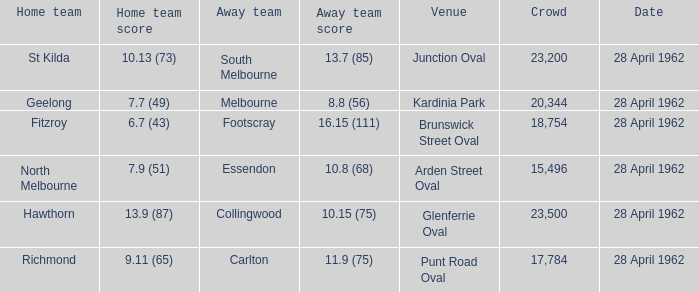What away team played at Brunswick Street Oval? Footscray. 